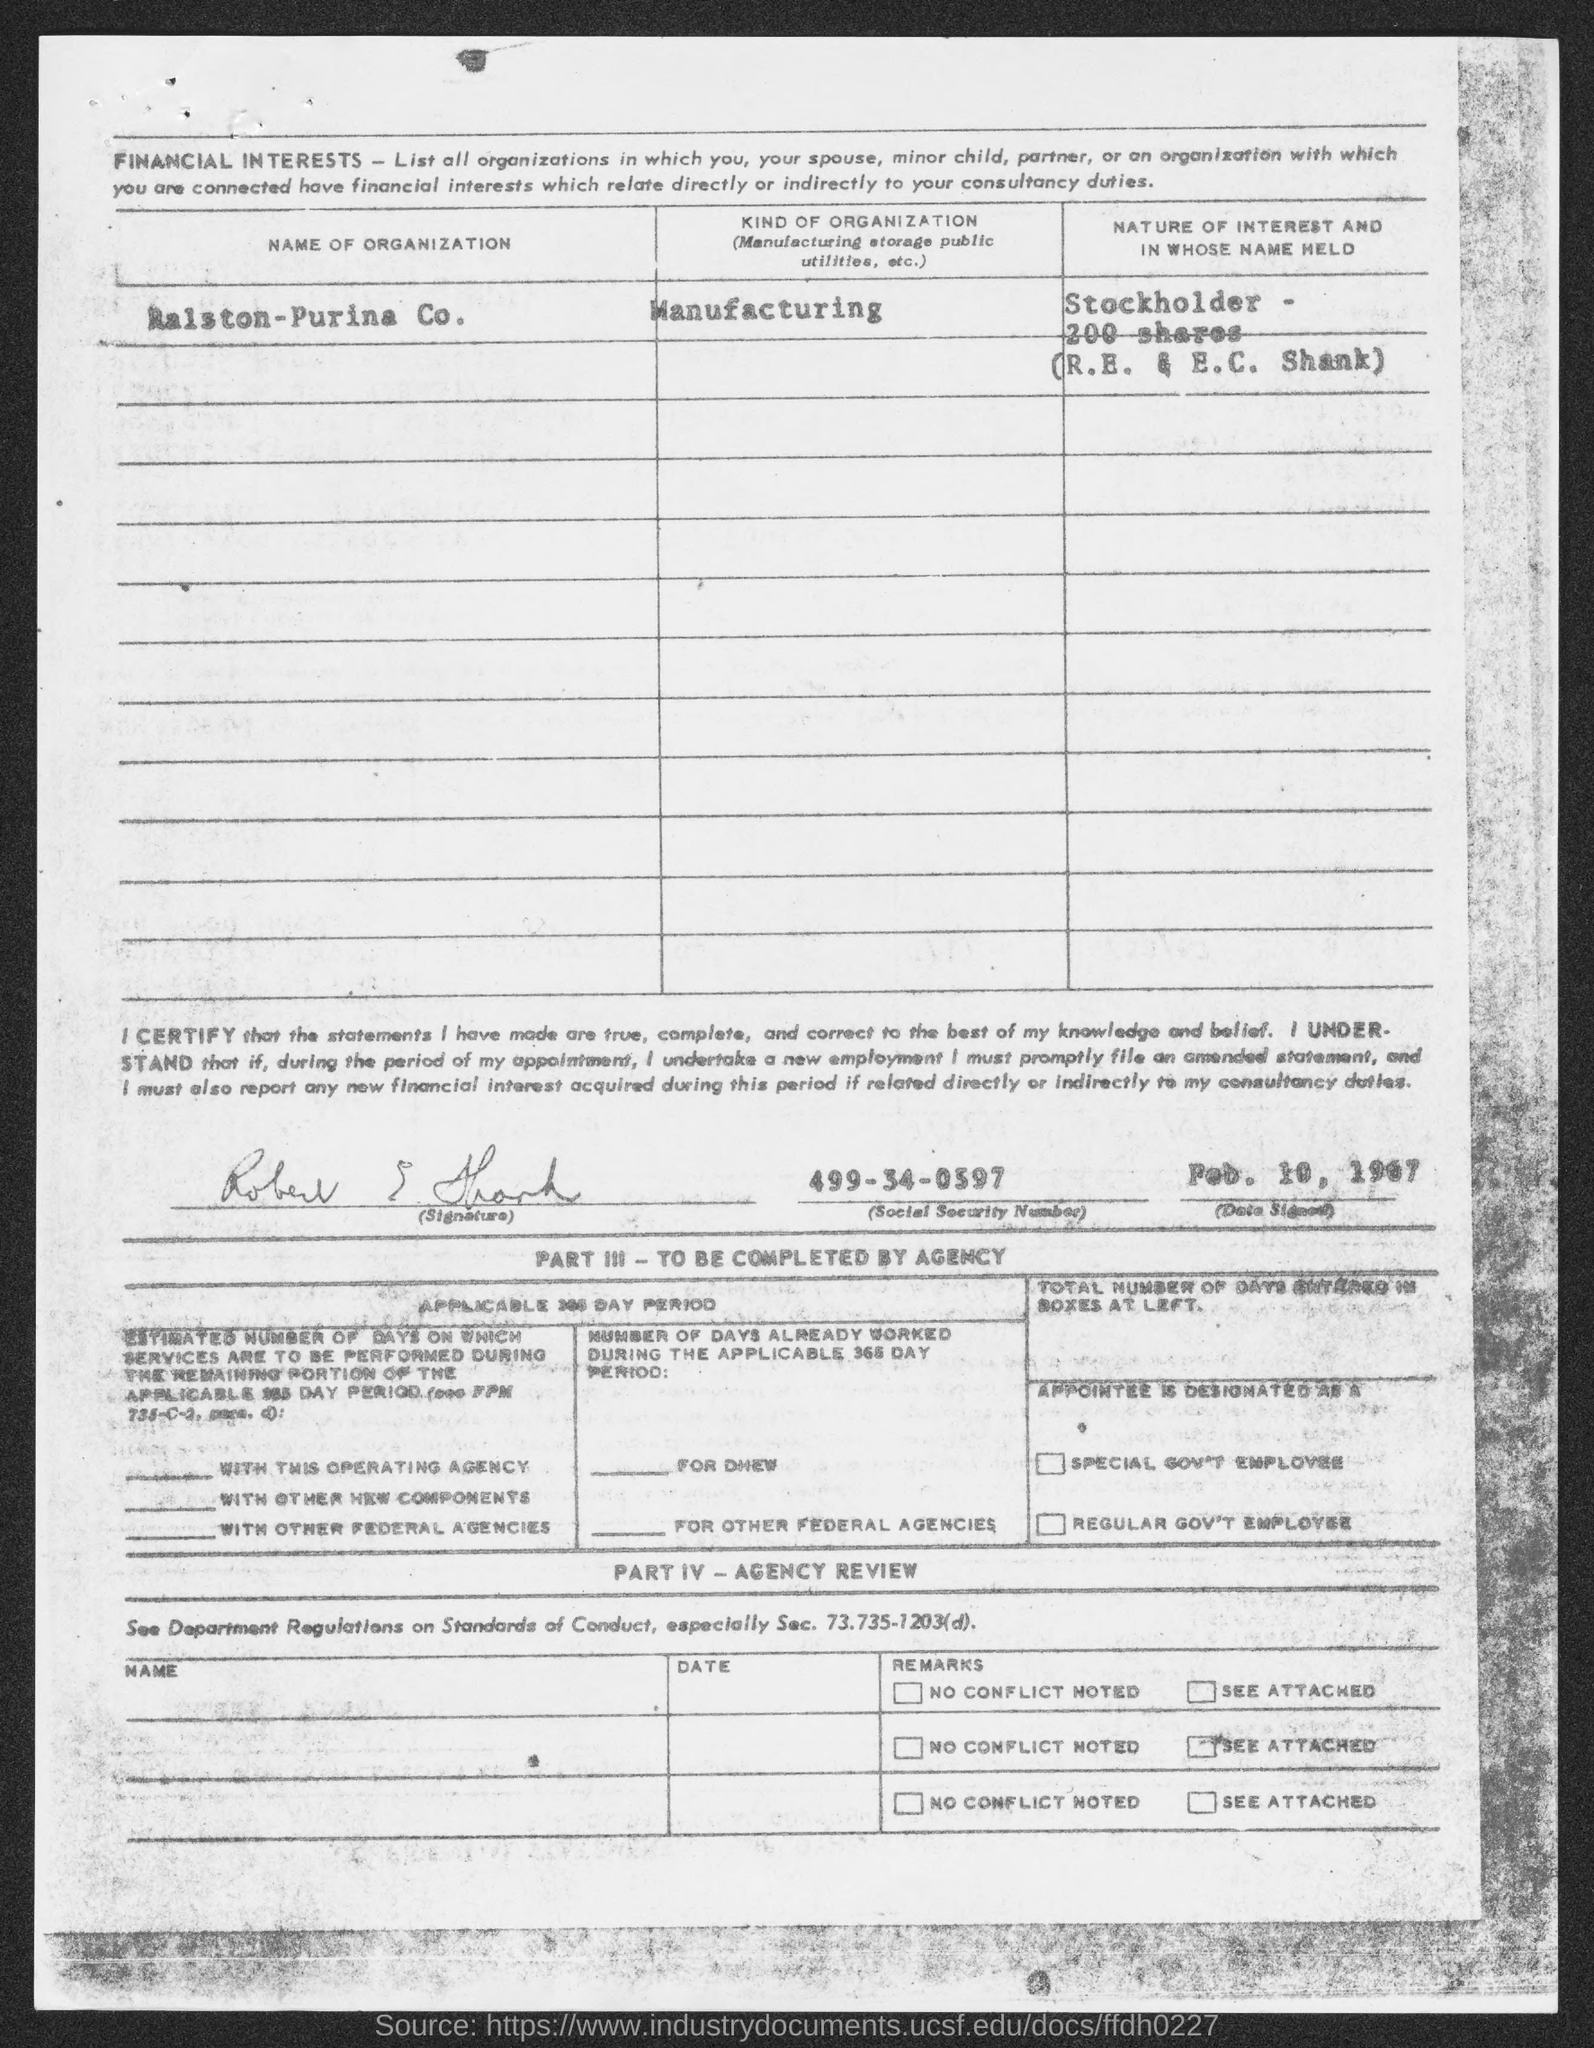Mention a couple of crucial points in this snapshot. The nature of interest is held by the stockholder, R.E. & E.C. Shank, and the shares are 200 in number. The document mentions a manufacturing organization. The name of the organization mentioned in the document is RAISTON-PURINA COMPANY. The date signed is February 10, 1967, as per the document. The social security number mentioned in the document is 499-34-0397. 